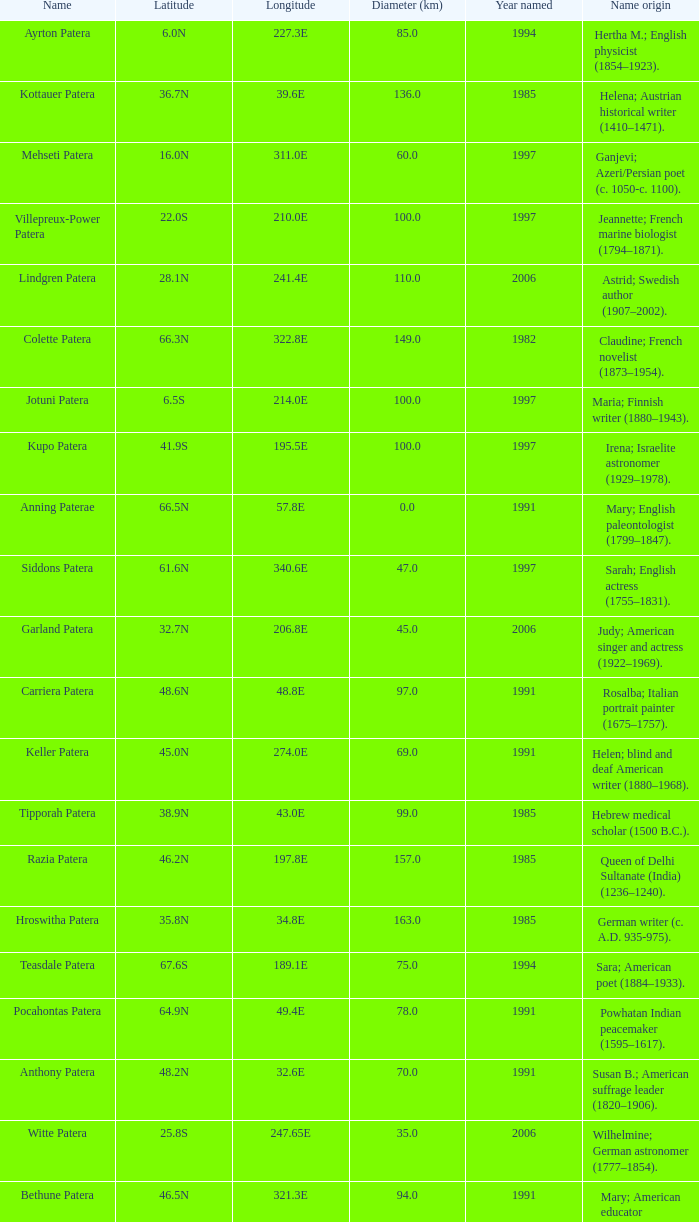What is  the diameter in km of the feature with a longitude of 40.2E?  135.0. 